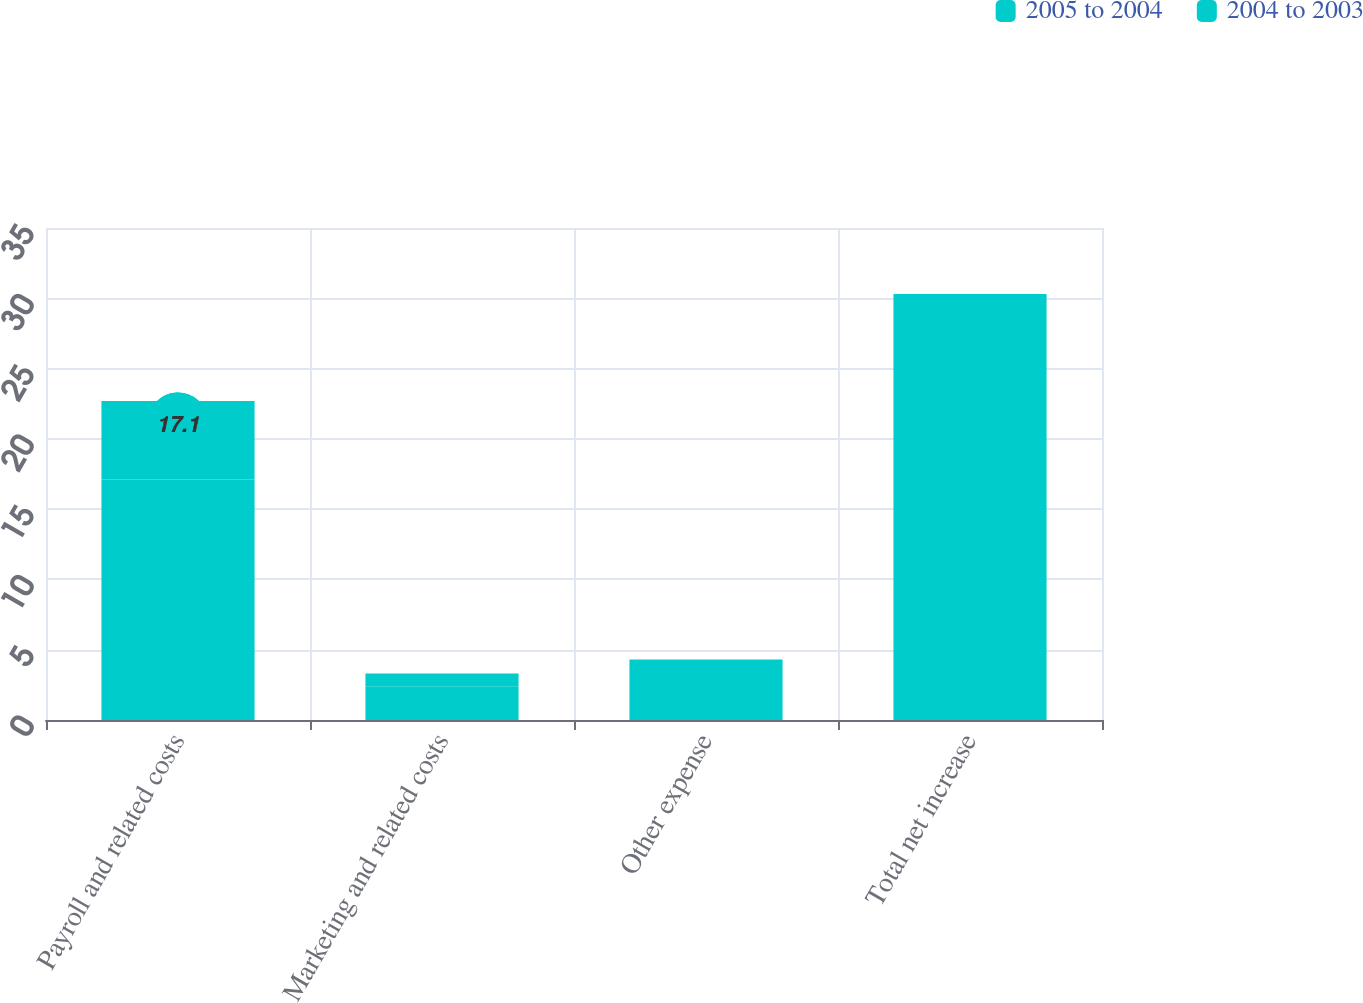Convert chart to OTSL. <chart><loc_0><loc_0><loc_500><loc_500><stacked_bar_chart><ecel><fcel>Payroll and related costs<fcel>Marketing and related costs<fcel>Other expense<fcel>Total net increase<nl><fcel>2005 to 2004<fcel>17.1<fcel>2.4<fcel>2.7<fcel>22.2<nl><fcel>2004 to 2003<fcel>5.6<fcel>0.9<fcel>1.6<fcel>8.1<nl></chart> 